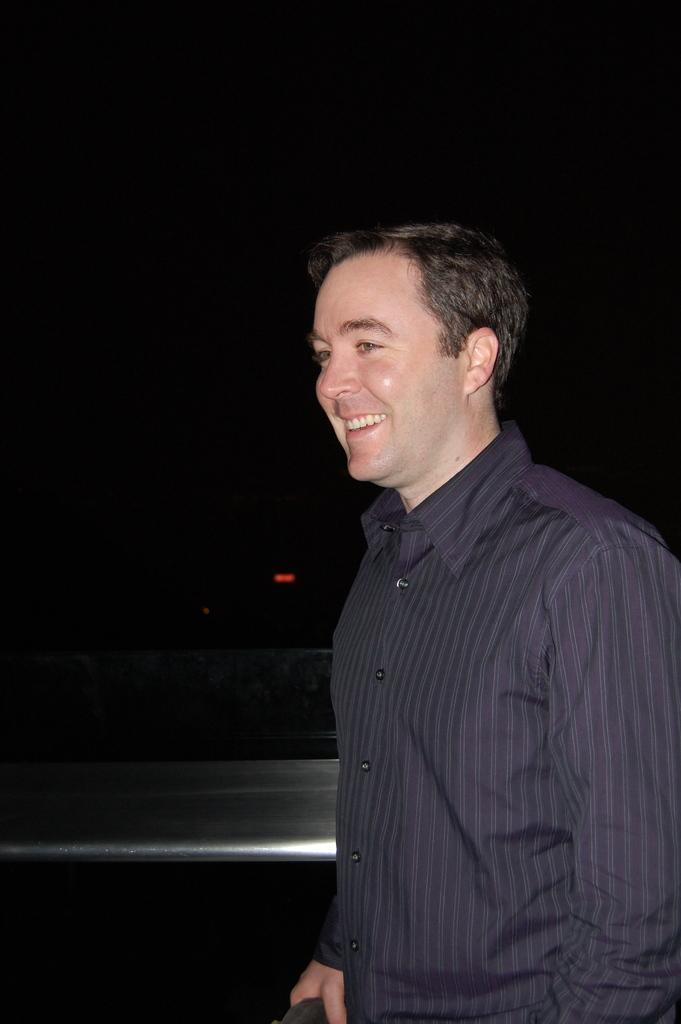Who is present in the image? There is a man in the image. What is the man wearing? The man is wearing a purple shirt. What material is the railing made of in the image? The railing in the image is made of metal. What is the color of the background in the image? The background of the image is dark. What type of can does the man use to represent his ideas in the image? There is no can present in the image, and the man is not using any object to represent his ideas. What is the size of the representative in the image? There is no representative present in the image, so it is not possible to determine its size. 